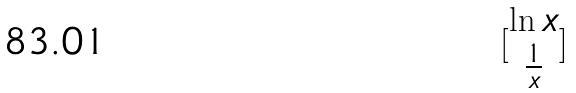<formula> <loc_0><loc_0><loc_500><loc_500>[ \begin{matrix} \ln x \\ \frac { 1 } { x } \end{matrix} ]</formula> 